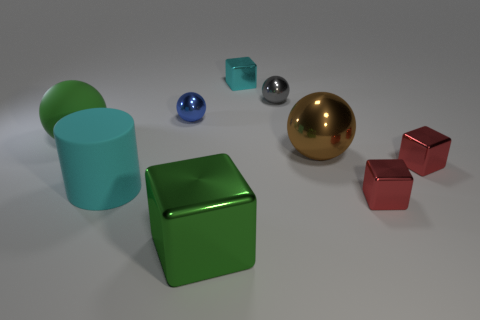Do the green rubber sphere and the blue metal thing have the same size?
Your response must be concise. No. What number of tiny red metal blocks are in front of the green object that is in front of the big cyan cylinder?
Your response must be concise. 0. Does the tiny blue object have the same shape as the gray thing?
Provide a short and direct response. Yes. What is the size of the blue metal object that is the same shape as the small gray metallic object?
Provide a short and direct response. Small. The large shiny thing behind the red metal cube behind the large cyan matte thing is what shape?
Ensure brevity in your answer.  Sphere. What is the size of the cyan block?
Your answer should be very brief. Small. What is the shape of the brown thing?
Your answer should be very brief. Sphere. There is a large brown thing; is its shape the same as the big rubber object in front of the large green rubber sphere?
Give a very brief answer. No. Does the big green thing right of the tiny blue sphere have the same shape as the cyan metal object?
Offer a very short reply. Yes. How many blocks are both behind the small gray shiny ball and to the right of the small cyan cube?
Ensure brevity in your answer.  0. 